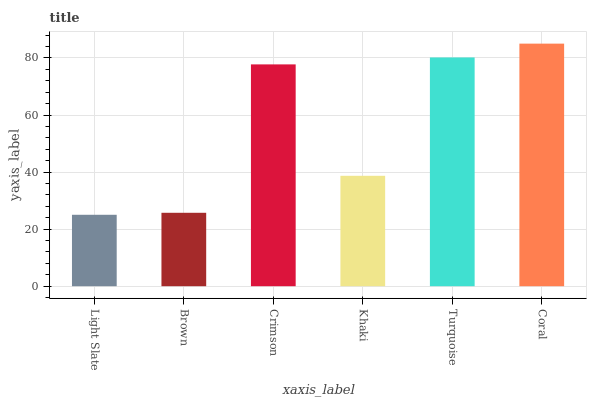Is Light Slate the minimum?
Answer yes or no. Yes. Is Coral the maximum?
Answer yes or no. Yes. Is Brown the minimum?
Answer yes or no. No. Is Brown the maximum?
Answer yes or no. No. Is Brown greater than Light Slate?
Answer yes or no. Yes. Is Light Slate less than Brown?
Answer yes or no. Yes. Is Light Slate greater than Brown?
Answer yes or no. No. Is Brown less than Light Slate?
Answer yes or no. No. Is Crimson the high median?
Answer yes or no. Yes. Is Khaki the low median?
Answer yes or no. Yes. Is Turquoise the high median?
Answer yes or no. No. Is Turquoise the low median?
Answer yes or no. No. 